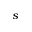Convert formula to latex. <formula><loc_0><loc_0><loc_500><loc_500>s</formula> 